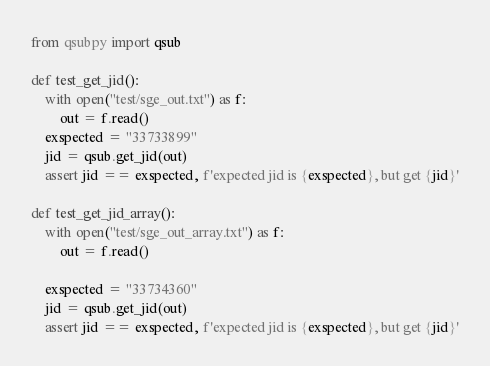Convert code to text. <code><loc_0><loc_0><loc_500><loc_500><_Python_>from qsubpy import qsub

def test_get_jid():
    with open("test/sge_out.txt") as f:
        out = f.read()
    exspected = "33733899"
    jid = qsub.get_jid(out)
    assert jid == exspected, f'expected jid is {exspected}, but get {jid}'

def test_get_jid_array():
    with open("test/sge_out_array.txt") as f:
        out = f.read()
    
    exspected = "33734360"
    jid = qsub.get_jid(out)
    assert jid == exspected, f'expected jid is {exspected}, but get {jid}'</code> 